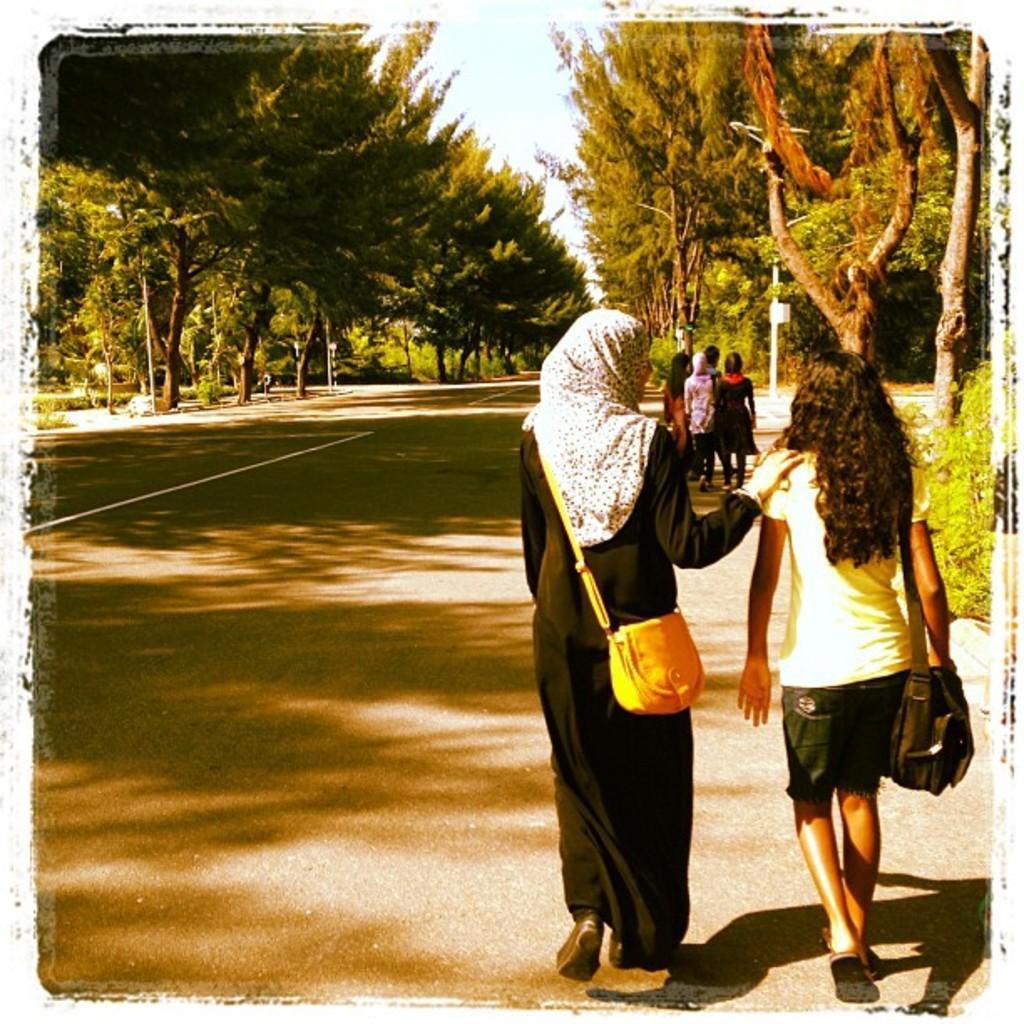Can you describe this image briefly? In this image I see 2 women who are on the path and they are the bags. In the background I see few people and the trees. 